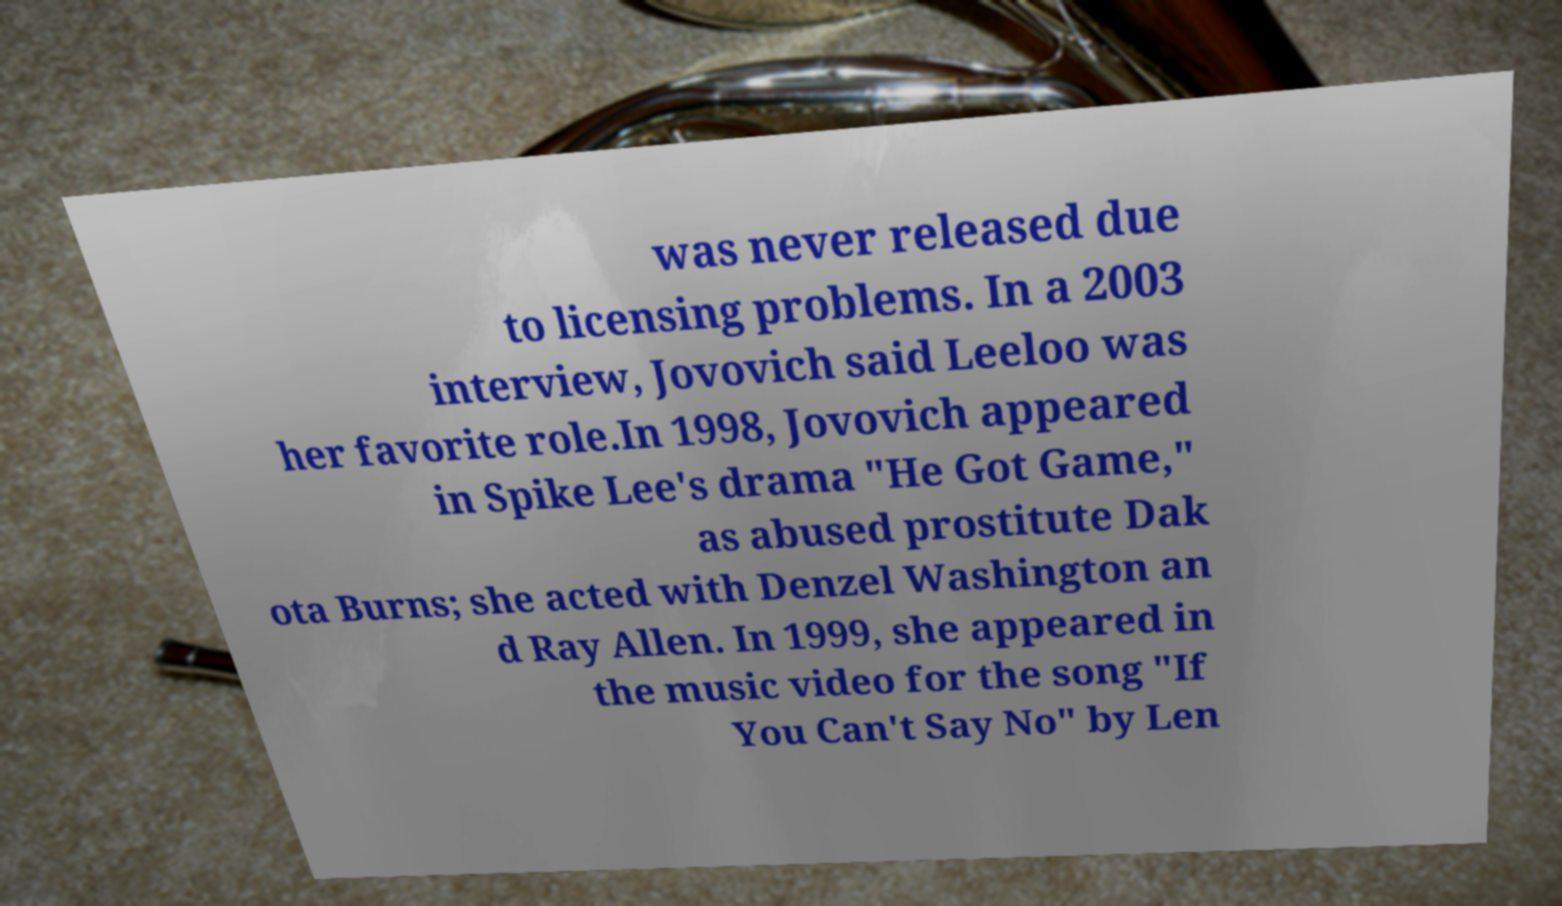Please read and relay the text visible in this image. What does it say? was never released due to licensing problems. In a 2003 interview, Jovovich said Leeloo was her favorite role.In 1998, Jovovich appeared in Spike Lee's drama "He Got Game," as abused prostitute Dak ota Burns; she acted with Denzel Washington an d Ray Allen. In 1999, she appeared in the music video for the song "If You Can't Say No" by Len 